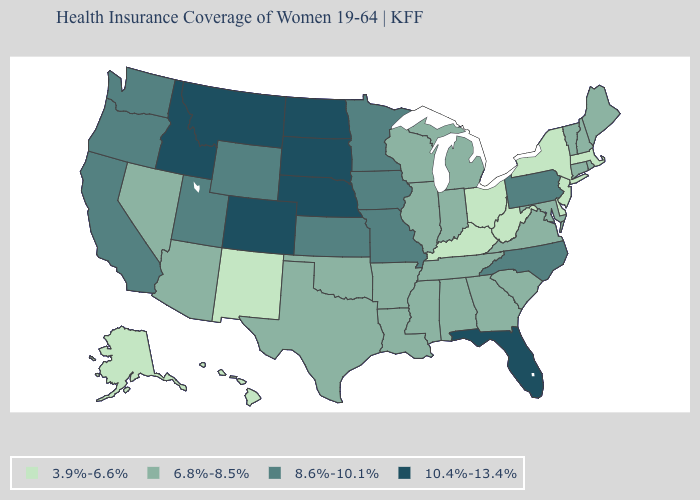What is the value of Kentucky?
Give a very brief answer. 3.9%-6.6%. Name the states that have a value in the range 6.8%-8.5%?
Be succinct. Alabama, Arizona, Arkansas, Connecticut, Georgia, Illinois, Indiana, Louisiana, Maine, Maryland, Michigan, Mississippi, Nevada, New Hampshire, Oklahoma, Rhode Island, South Carolina, Tennessee, Texas, Vermont, Virginia, Wisconsin. What is the highest value in the USA?
Keep it brief. 10.4%-13.4%. Name the states that have a value in the range 8.6%-10.1%?
Write a very short answer. California, Iowa, Kansas, Minnesota, Missouri, North Carolina, Oregon, Pennsylvania, Utah, Washington, Wyoming. Name the states that have a value in the range 10.4%-13.4%?
Quick response, please. Colorado, Florida, Idaho, Montana, Nebraska, North Dakota, South Dakota. Name the states that have a value in the range 8.6%-10.1%?
Answer briefly. California, Iowa, Kansas, Minnesota, Missouri, North Carolina, Oregon, Pennsylvania, Utah, Washington, Wyoming. What is the value of Washington?
Keep it brief. 8.6%-10.1%. What is the value of Connecticut?
Be succinct. 6.8%-8.5%. Which states hav the highest value in the MidWest?
Concise answer only. Nebraska, North Dakota, South Dakota. Name the states that have a value in the range 3.9%-6.6%?
Answer briefly. Alaska, Delaware, Hawaii, Kentucky, Massachusetts, New Jersey, New Mexico, New York, Ohio, West Virginia. Does Tennessee have the highest value in the USA?
Keep it brief. No. What is the value of Oregon?
Write a very short answer. 8.6%-10.1%. Among the states that border Massachusetts , does New York have the highest value?
Quick response, please. No. Among the states that border Minnesota , which have the lowest value?
Keep it brief. Wisconsin. 